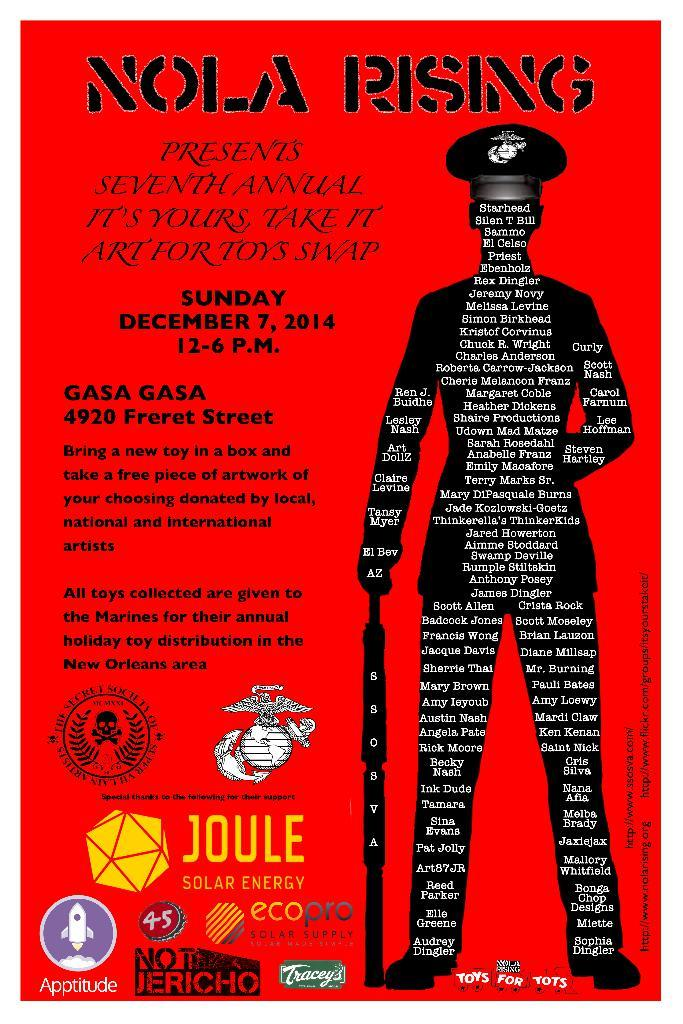What type of visual is the image? The image is a poster. What can be found on the poster besides the person's picture? There is text written on the poster, and there are logos present as well. What is the person in the picture holding? The person in the picture is holding something. Can you describe the person's attire in the picture? The person in the picture is wearing a cap. What type of sponge can be seen in the person's hand in the image? There is no sponge visible in the person's hand in the image. What type of land is depicted in the background of the poster? There is no land depicted in the background of the poster; it is a poster with text, logos, and a person's picture. 